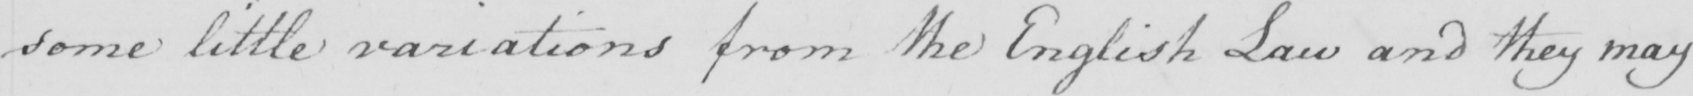Can you tell me what this handwritten text says? some little variations from the English Law and they may 